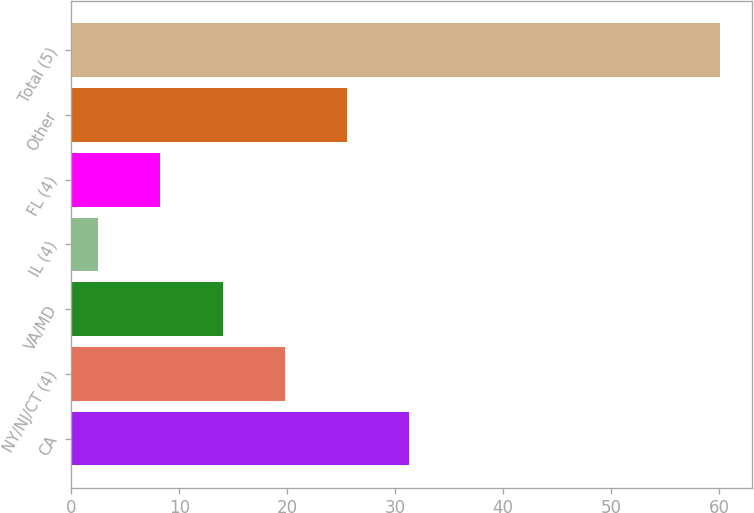Convert chart. <chart><loc_0><loc_0><loc_500><loc_500><bar_chart><fcel>CA<fcel>NY/NJ/CT (4)<fcel>VA/MD<fcel>IL (4)<fcel>FL (4)<fcel>Other<fcel>Total (5)<nl><fcel>31.3<fcel>19.78<fcel>14.02<fcel>2.5<fcel>8.26<fcel>25.54<fcel>60.1<nl></chart> 